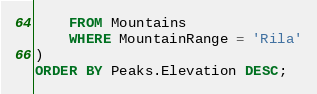<code> <loc_0><loc_0><loc_500><loc_500><_SQL_>    FROM Mountains
    WHERE MountainRange = 'Rila'
)
ORDER BY Peaks.Elevation DESC;</code> 